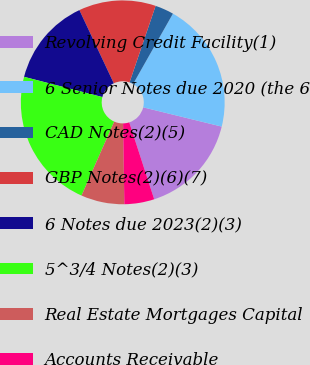Convert chart. <chart><loc_0><loc_0><loc_500><loc_500><pie_chart><fcel>Revolving Credit Facility(1)<fcel>6 Senior Notes due 2020 (the 6<fcel>CAD Notes(2)(5)<fcel>GBP Notes(2)(6)(7)<fcel>6 Notes due 2023(2)(3)<fcel>5^3/4 Notes(2)(3)<fcel>Real Estate Mortgages Capital<fcel>Accounts Receivable<nl><fcel>16.18%<fcel>20.63%<fcel>2.97%<fcel>12.22%<fcel>13.98%<fcel>22.4%<fcel>6.88%<fcel>4.74%<nl></chart> 